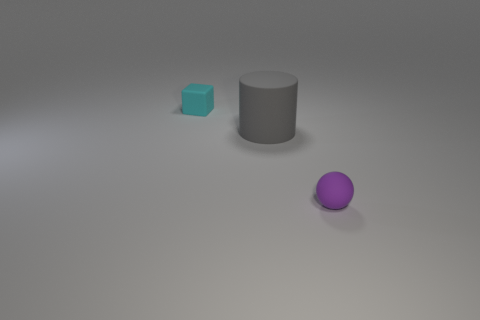Add 3 big gray metal cylinders. How many objects exist? 6 Subtract all cubes. How many objects are left? 2 Subtract all tiny things. Subtract all small green cubes. How many objects are left? 1 Add 3 small rubber spheres. How many small rubber spheres are left? 4 Add 2 tiny cyan matte things. How many tiny cyan matte things exist? 3 Subtract 0 yellow cylinders. How many objects are left? 3 